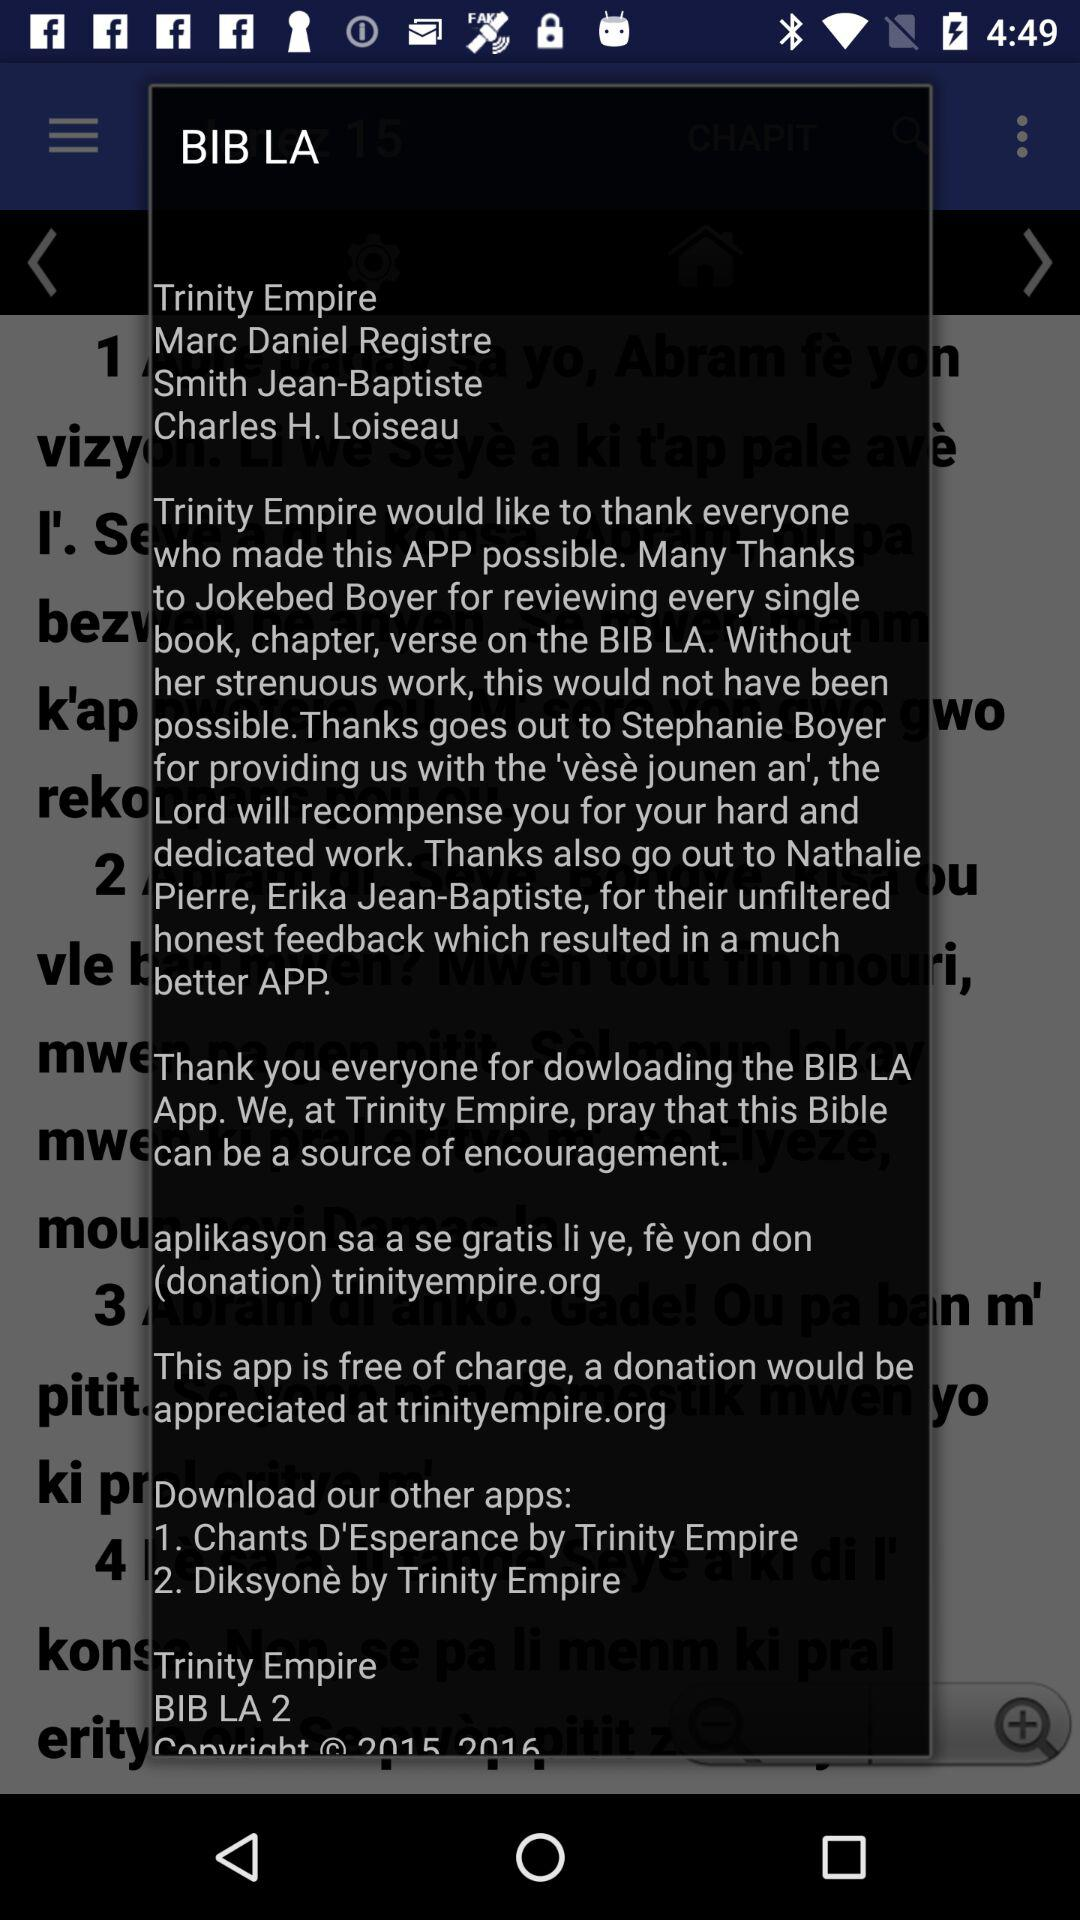What are the mentioned names? The mentioned names are Trinity Empire, Marc Daniel Registre, Smith Jean-Baptiste and Charles H. Loiseau. 